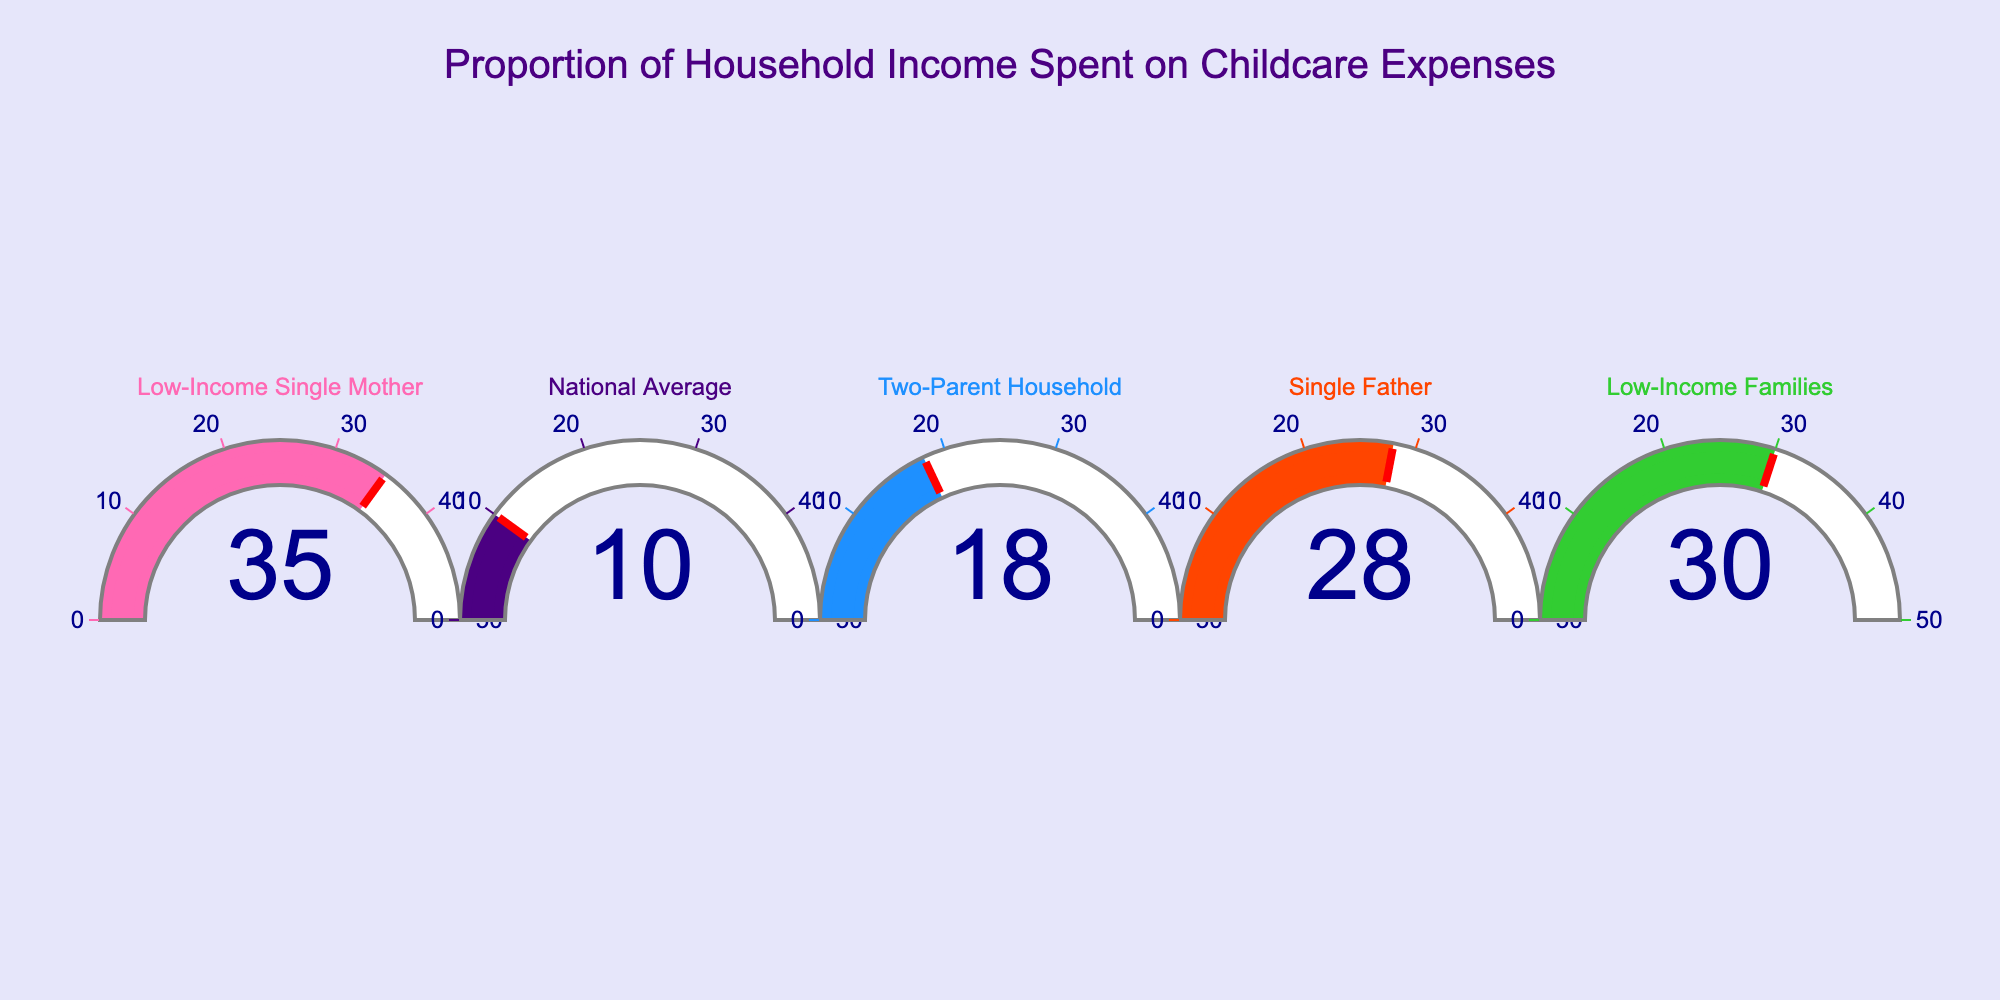what's the title of the figure? The title is located at the top center of the figure. It reads: "Proportion of Household Income Spent on Childcare Expenses".
Answer: Proportion of Household Income Spent on Childcare Expenses How many categories are represented in the figure? By counting the gauges, you can see there are five different categories displayed.
Answer: Five Which category shows the highest proportion of household income spent on childcare expenses? Each gauge displays a percentage. The "Low-Income Single Mother" category has the highest percentage at 35%.
Answer: Low-Income Single Mother Which category shows the lowest proportion of household income spent on childcare expenses? By comparing the numbers in each gauge, "National Average" has the lowest value at 10%.
Answer: National Average What is the proportion of household income spent on childcare expenses for Low-Income Families? The gauge labeled "Low-Income Families" shows the percentage directly, which is 30%.
Answer: 30% What is the difference in the proportion of household income spent on childcare between Two-Parent Households and Single Fathers? The gauge for Two-Parent Household shows 18% and for Single Father is 28%. The difference is 28% - 18%.
Answer: 10% How does the proportion of household income spent on childcare for Single Fathers compare to the National Average? The gauge for Single Fathers shows 28%, while the National Average is 10%. 28% is greater than 10%.
Answer: Single Fathers spend more What is the combined percent of household income spent on childcare for Low-Income Single Mothers and Low-Income Families? The gauge for Low-Income Single Mothers shows 35% and Low-Income Families show 30%. The combined percent is 35% + 30%.
Answer: 65% Which category has a lower proportion of income spent on childcare: Two-Parent Household or Low-Income Families? The gauge for Two-Parent Household is at 18%, while for Low-Income Families it is 30%. Therefore, 18% is lower than 30%.
Answer: Two-Parent Household 